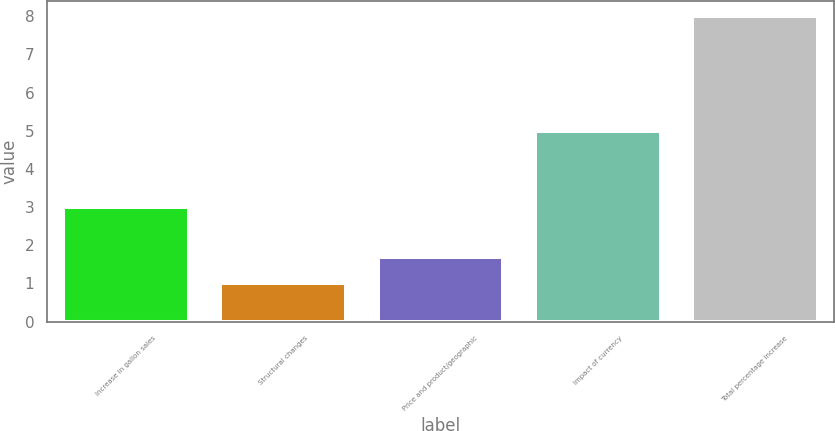Convert chart. <chart><loc_0><loc_0><loc_500><loc_500><bar_chart><fcel>Increase in gallon sales<fcel>Structural changes<fcel>Price and product/geographic<fcel>Impact of currency<fcel>Total percentage increase<nl><fcel>3<fcel>1<fcel>1.7<fcel>5<fcel>8<nl></chart> 